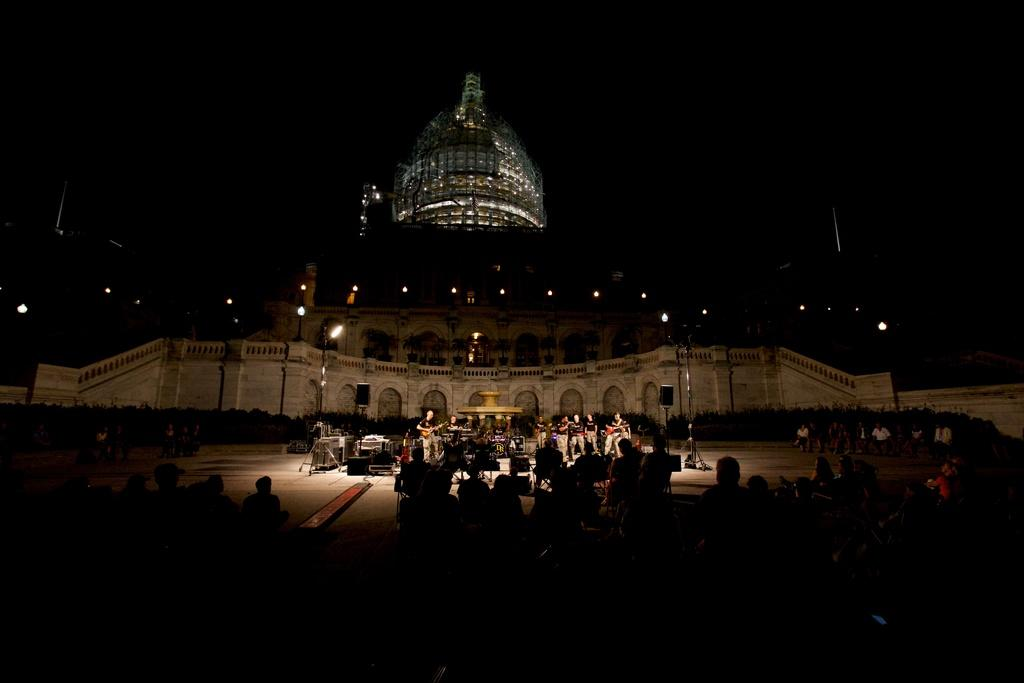How many groups of persons can be seen in the image? There are two groups of persons in the image. What can be seen in the background behind the groups of persons? A: In the background, there are musical instruments, a water sculpture fountain, another group of persons, trees, lights, a building, and the sky. What type of structure is present in the background? There is a building in the background. What natural elements are present in the background? Trees are present in the background. What type of lace is being used to decorate the men in the image? There is no lace present in the image, nor are any men being decorated with lace. 